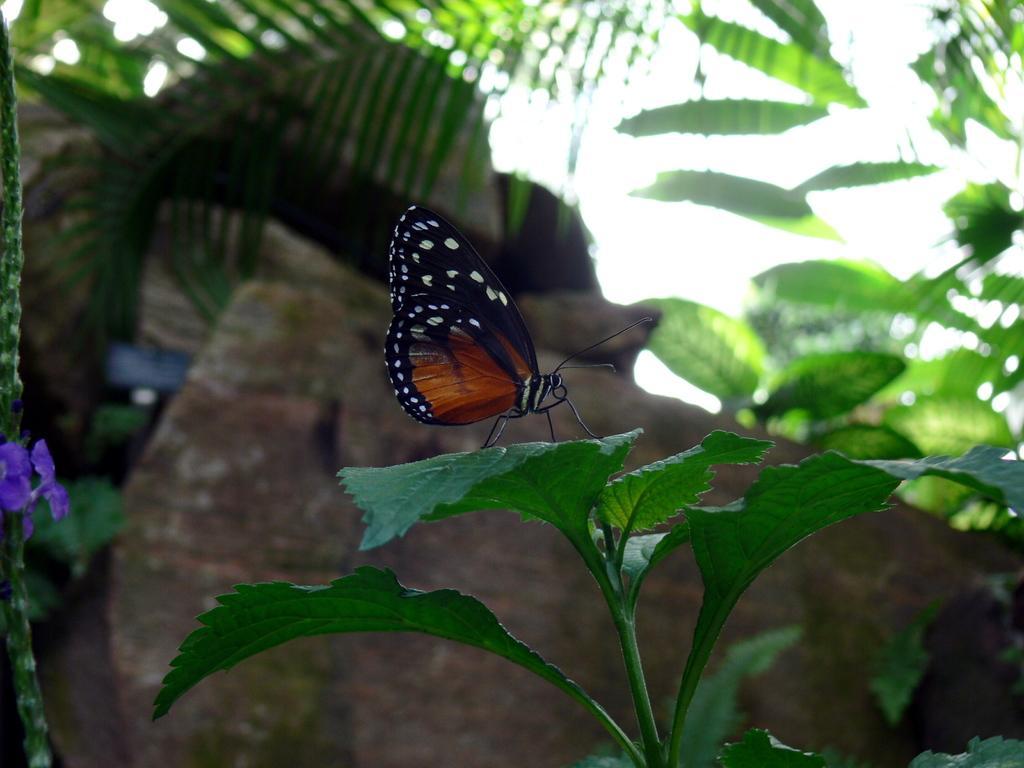In one or two sentences, can you explain what this image depicts? In the center of the image there is a butterfly on the plant. In the background of the image there are rocks. In the background of the image their leaves. 